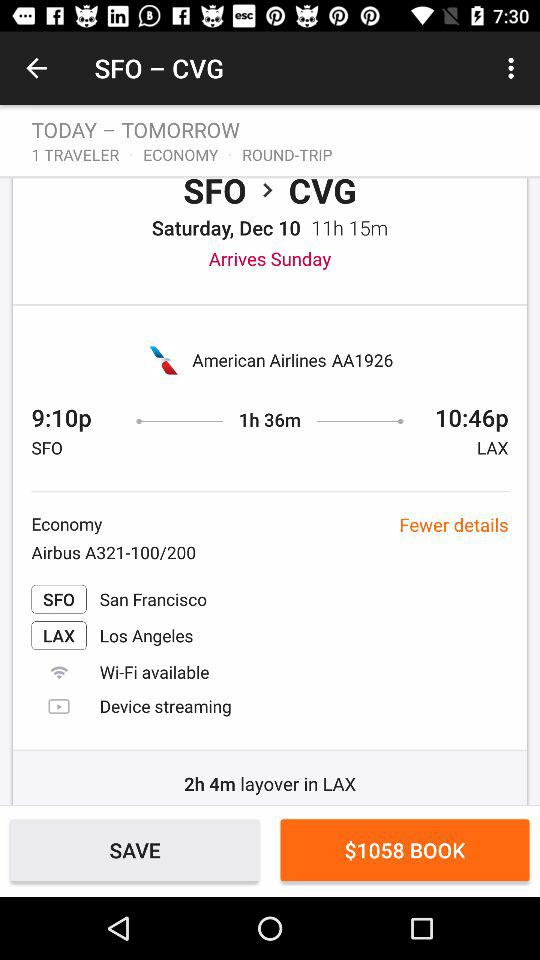For what date is the flight booked? The flight is booked for Sunday, December 10. 